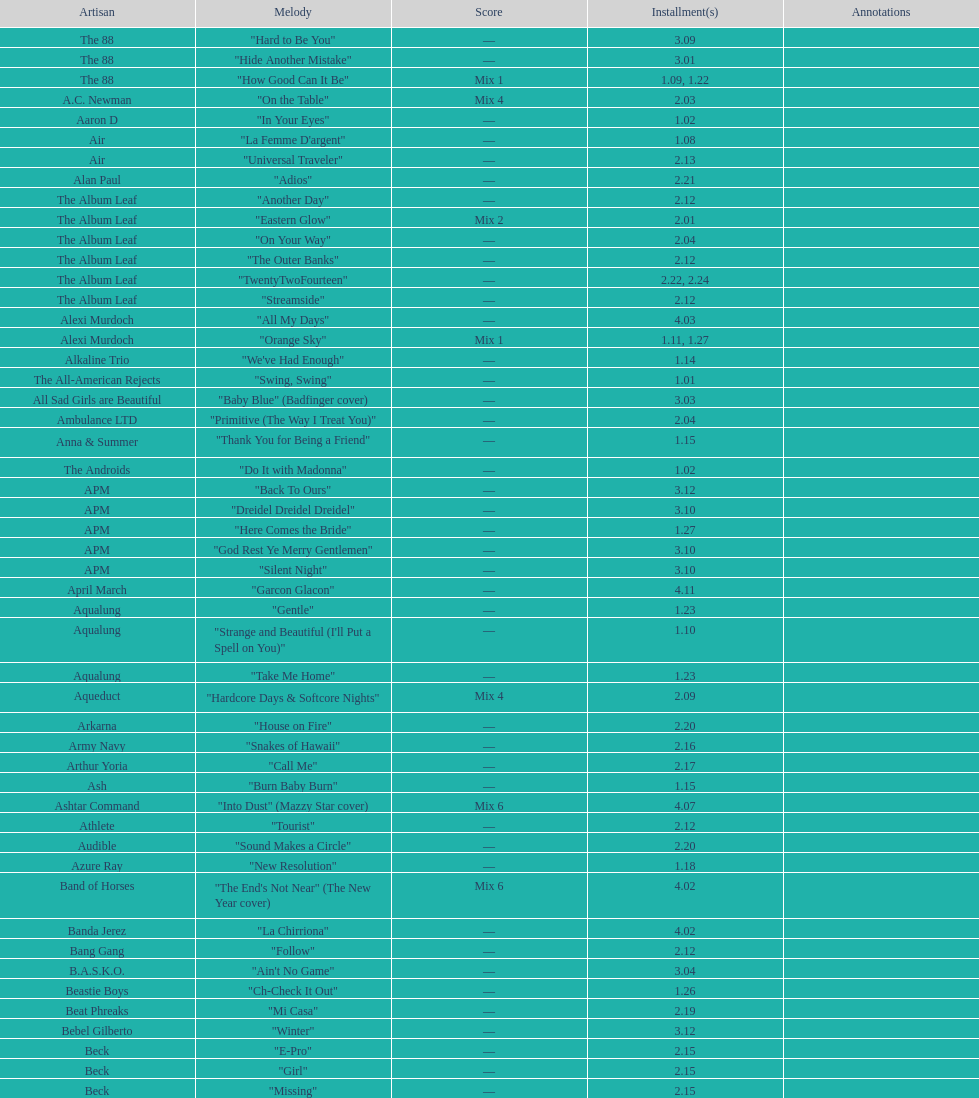The artist ash only had one song that appeared in the o.c. what is the name of that song? "Burn Baby Burn". 